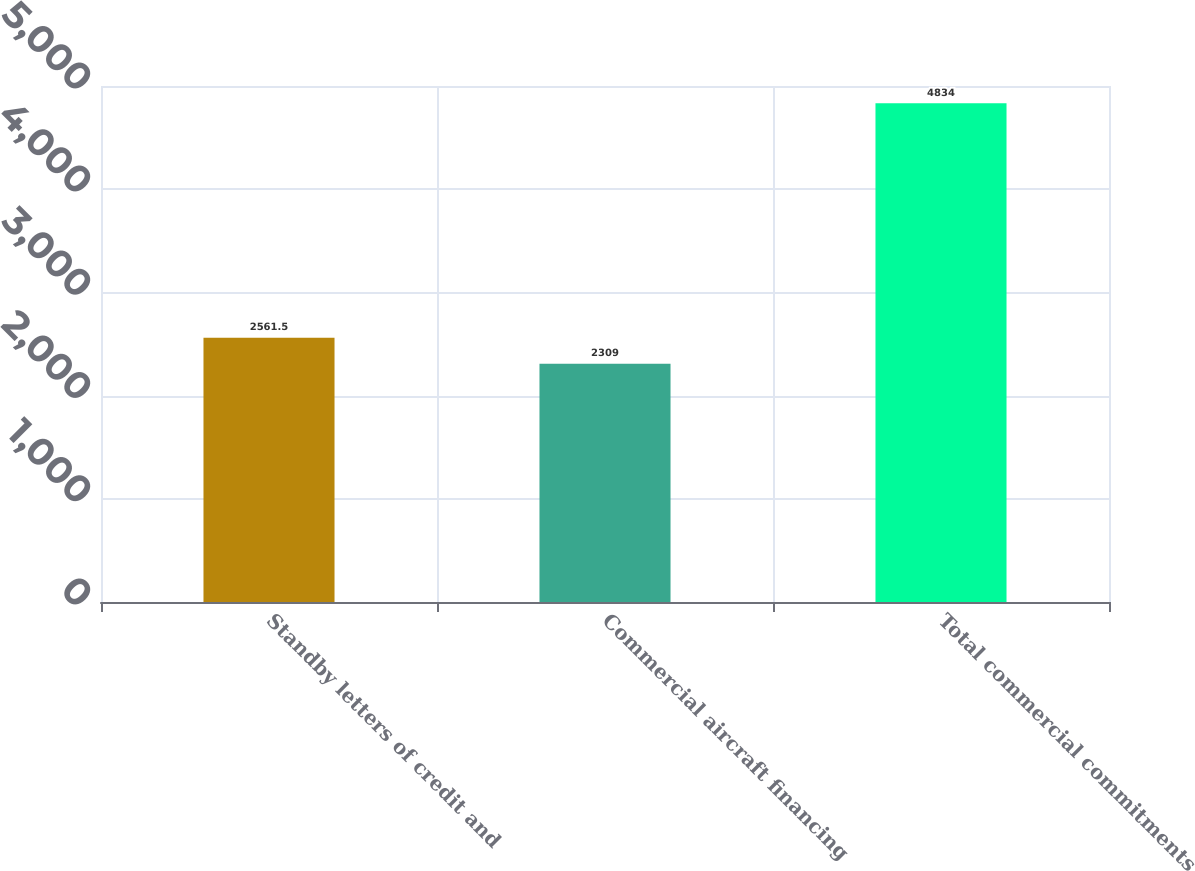Convert chart to OTSL. <chart><loc_0><loc_0><loc_500><loc_500><bar_chart><fcel>Standby letters of credit and<fcel>Commercial aircraft financing<fcel>Total commercial commitments<nl><fcel>2561.5<fcel>2309<fcel>4834<nl></chart> 